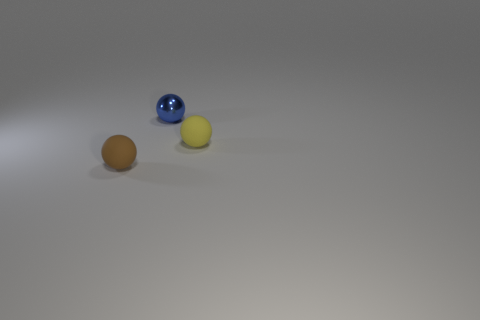What color is the small matte object left of the sphere to the right of the tiny blue sphere?
Offer a very short reply. Brown. What material is the brown thing that is the same shape as the blue metal object?
Your response must be concise. Rubber. How many metallic objects are either blue balls or small brown things?
Provide a succinct answer. 1. Are the small sphere that is to the right of the small blue shiny thing and the tiny sphere that is on the left side of the tiny blue object made of the same material?
Your answer should be very brief. Yes. Are there any tiny green cylinders?
Make the answer very short. No. Do the tiny rubber object on the left side of the metallic object and the thing right of the small metal object have the same shape?
Give a very brief answer. Yes. Is there a yellow thing that has the same material as the tiny brown sphere?
Ensure brevity in your answer.  Yes. Is the tiny ball that is on the right side of the small blue object made of the same material as the brown ball?
Ensure brevity in your answer.  Yes. Is the number of rubber spheres to the right of the tiny blue shiny ball greater than the number of small brown rubber spheres that are behind the small brown thing?
Ensure brevity in your answer.  Yes. What is the color of the rubber thing that is the same size as the yellow sphere?
Ensure brevity in your answer.  Brown. 